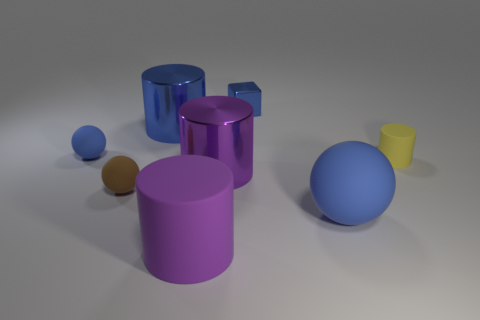Do the tiny shiny thing and the tiny cylinder have the same color?
Provide a short and direct response. No. How many rubber things are small yellow cylinders or blue cubes?
Offer a terse response. 1. What number of cylinders are there?
Provide a succinct answer. 4. Is the tiny cylinder on the right side of the small blue rubber sphere made of the same material as the blue ball left of the blue metal cube?
Keep it short and to the point. Yes. What is the color of the other small object that is the same shape as the purple matte object?
Offer a terse response. Yellow. The small sphere behind the big purple cylinder behind the big matte sphere is made of what material?
Your answer should be very brief. Rubber. There is a blue object that is in front of the tiny blue matte object; is it the same shape as the small blue object on the left side of the blue metal cube?
Offer a very short reply. Yes. What size is the blue object that is both right of the small brown thing and to the left of the blue cube?
Your answer should be very brief. Large. How many other things are there of the same color as the tiny cylinder?
Ensure brevity in your answer.  0. Do the tiny sphere that is behind the small cylinder and the brown sphere have the same material?
Give a very brief answer. Yes. 